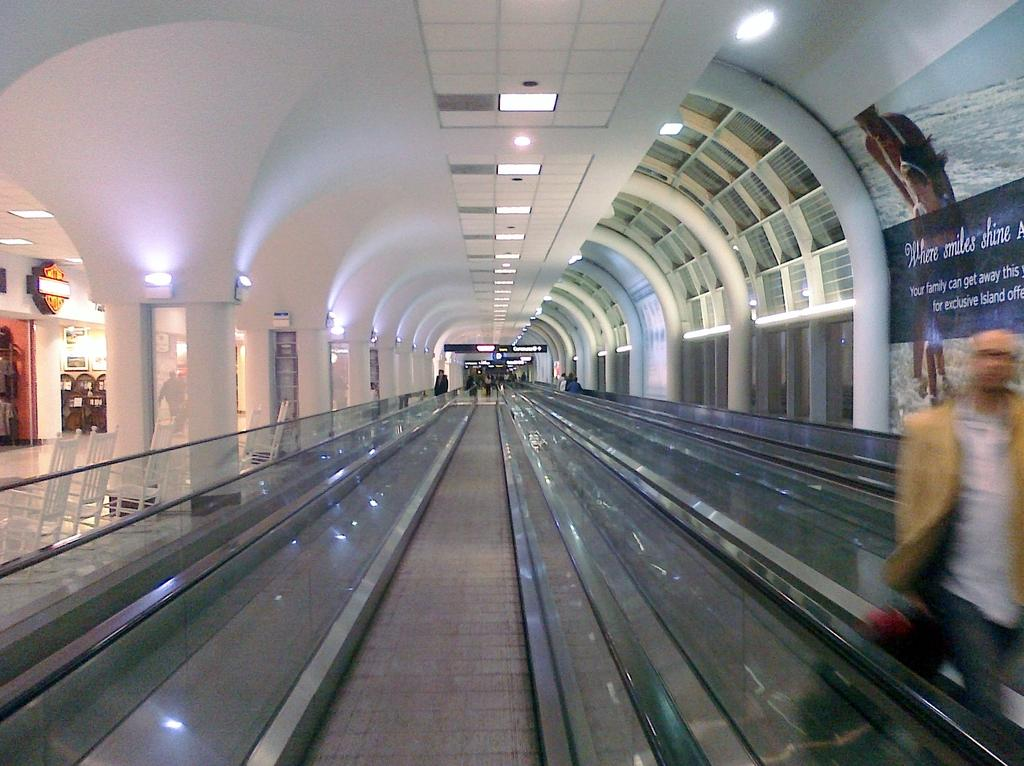<image>
Relay a brief, clear account of the picture shown. A sign that says where smiles shine hangs over a moving walkway. 